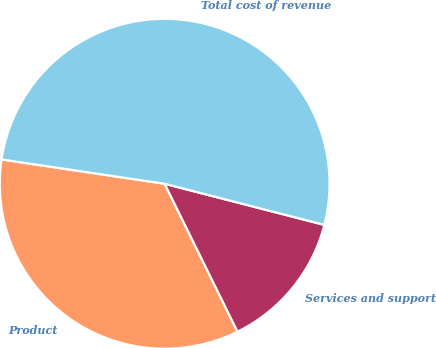<chart> <loc_0><loc_0><loc_500><loc_500><pie_chart><fcel>Product<fcel>Services and support<fcel>Total cost of revenue<nl><fcel>34.64%<fcel>13.7%<fcel>51.65%<nl></chart> 